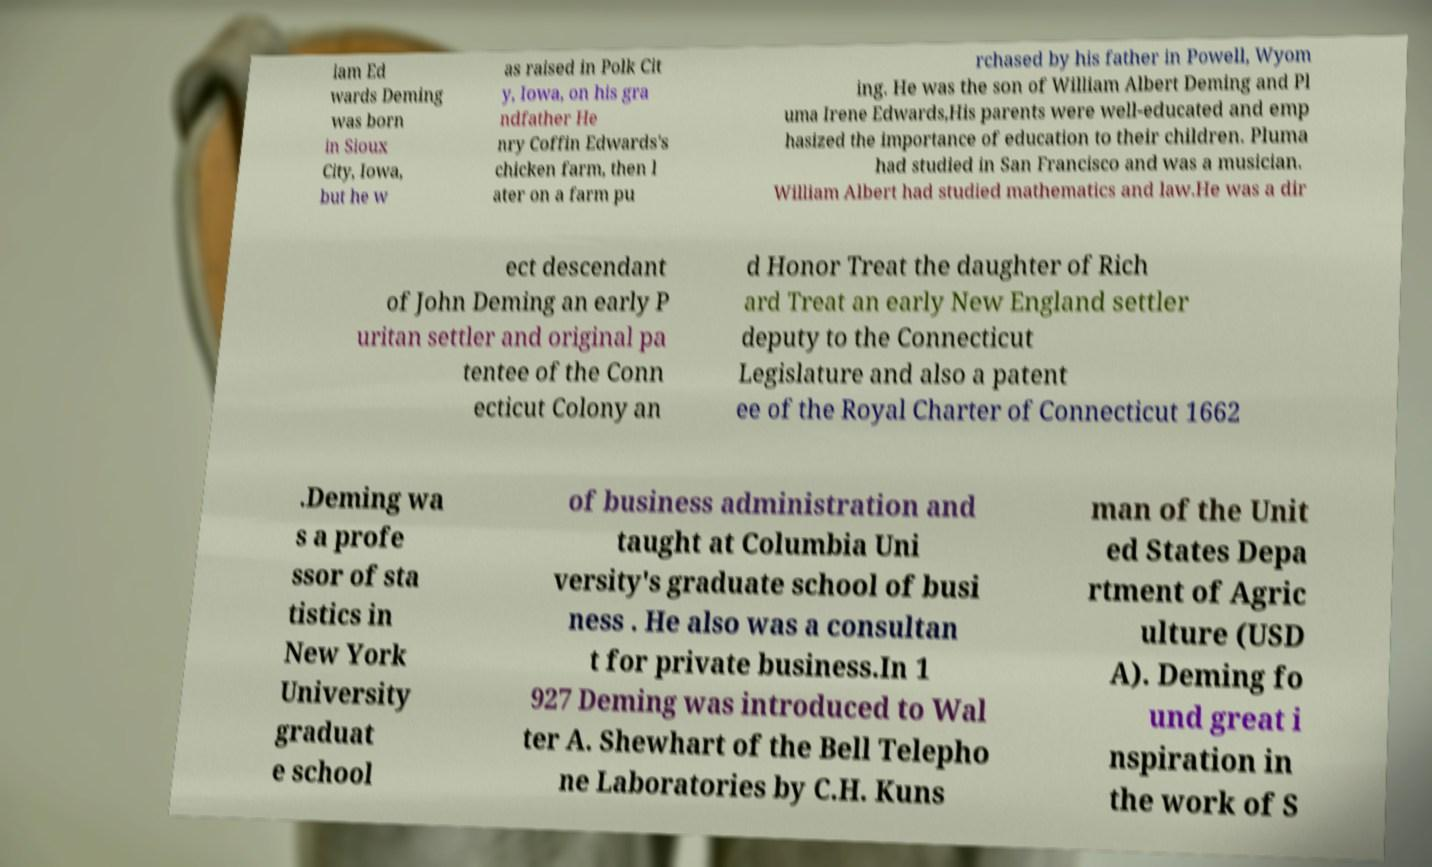Please read and relay the text visible in this image. What does it say? iam Ed wards Deming was born in Sioux City, Iowa, but he w as raised in Polk Cit y, Iowa, on his gra ndfather He nry Coffin Edwards's chicken farm, then l ater on a farm pu rchased by his father in Powell, Wyom ing. He was the son of William Albert Deming and Pl uma Irene Edwards,His parents were well-educated and emp hasized the importance of education to their children. Pluma had studied in San Francisco and was a musician. William Albert had studied mathematics and law.He was a dir ect descendant of John Deming an early P uritan settler and original pa tentee of the Conn ecticut Colony an d Honor Treat the daughter of Rich ard Treat an early New England settler deputy to the Connecticut Legislature and also a patent ee of the Royal Charter of Connecticut 1662 .Deming wa s a profe ssor of sta tistics in New York University graduat e school of business administration and taught at Columbia Uni versity's graduate school of busi ness . He also was a consultan t for private business.In 1 927 Deming was introduced to Wal ter A. Shewhart of the Bell Telepho ne Laboratories by C.H. Kuns man of the Unit ed States Depa rtment of Agric ulture (USD A). Deming fo und great i nspiration in the work of S 